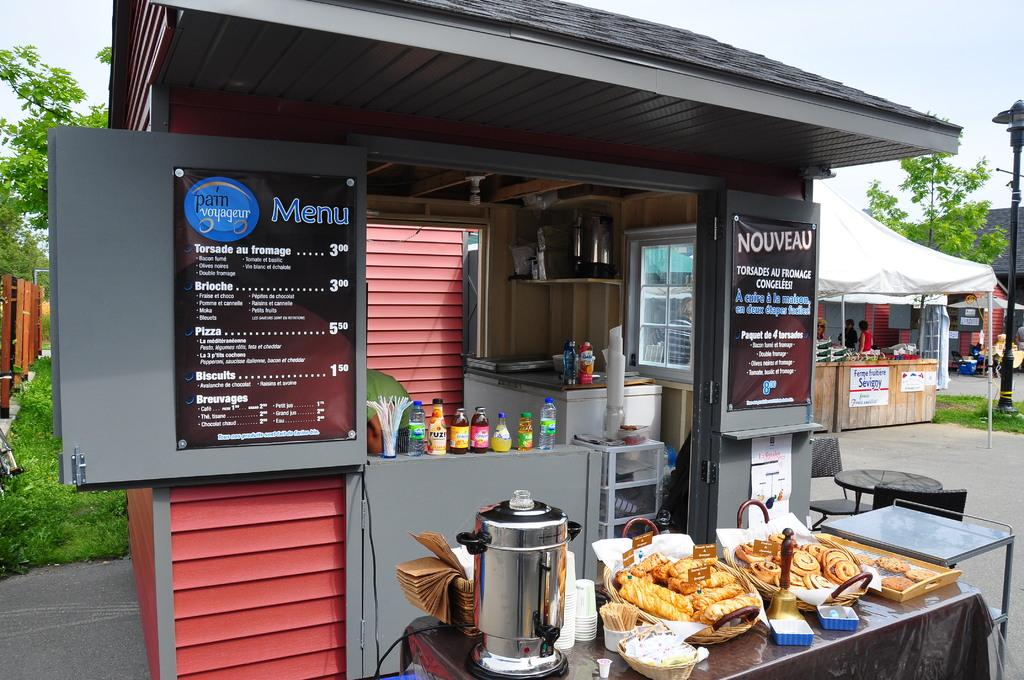Provide a one-sentence caption for the provided image. A small food stand has signs reading Menu and Nouveau. 